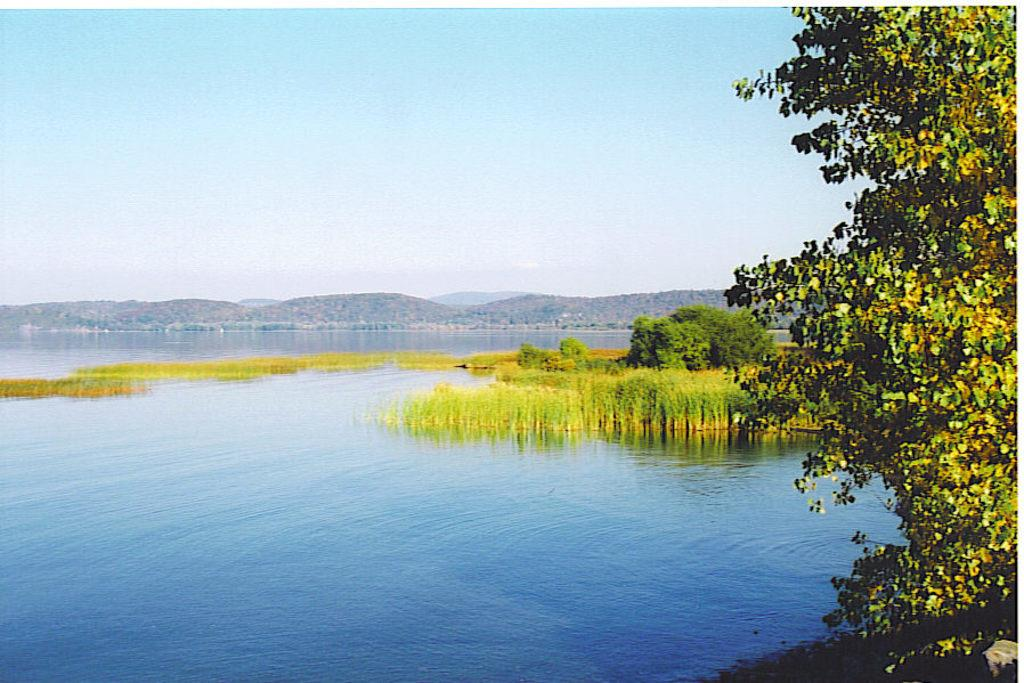What is the primary element present in the image? There is water in the image. What types of vegetation can be seen in the image? There are plants and trees in the image. What geographical feature is visible in the image? There are mountains in the image. What part of the natural environment is visible in the image? The sky is visible in the image. How many jellyfish can be seen swimming in the water in the image? There are no jellyfish present in the image; it features water, plants, trees, mountains, and the sky. What type of toys are scattered on the island in the image? There is no island or toys present in the image. 